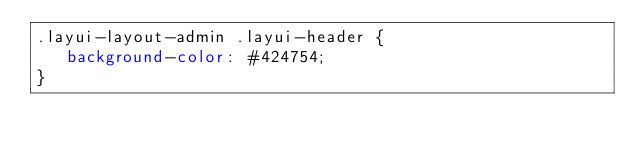<code> <loc_0><loc_0><loc_500><loc_500><_CSS_>.layui-layout-admin .layui-header {
   background-color: #424754;
}



</code> 